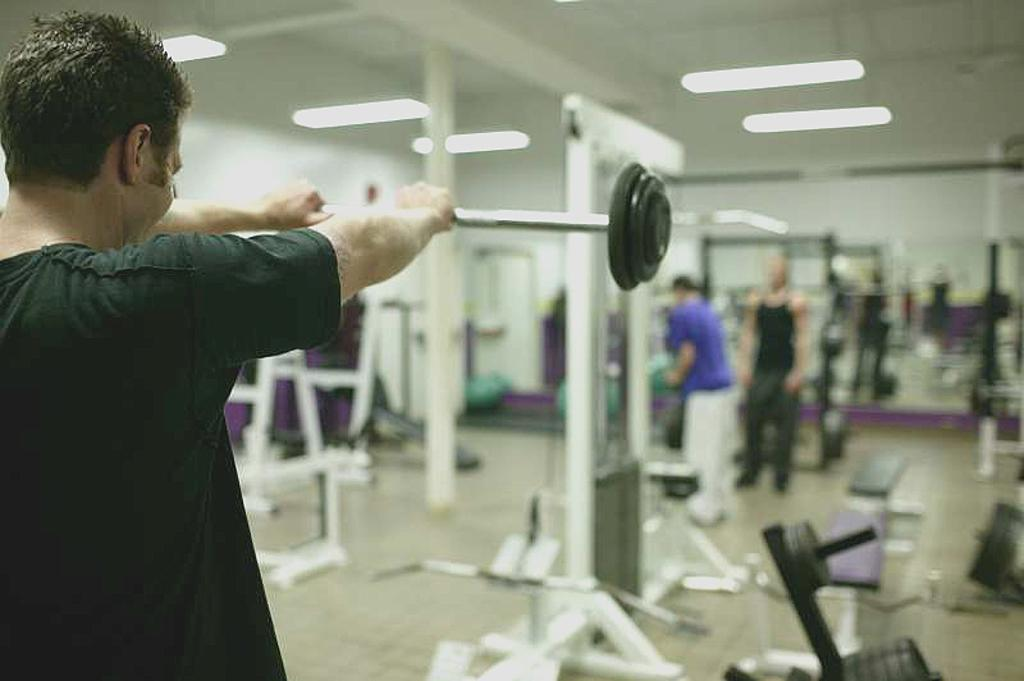What is the man on the left side of the image doing? The man on the left side of the image is lifting weights. What can be seen in the image besides the man lifting weights? There are stands, people, a wall in the background, and lights visible at the top of the image. Can you describe the stands in the image? Unfortunately, the provided facts do not give enough information to describe the stands in detail. What is the purpose of the lights visible at the top of the image? The lights are likely for illumination during the activity in the image. What type of discovery can be seen in the image? There is no discovery present in the image. 